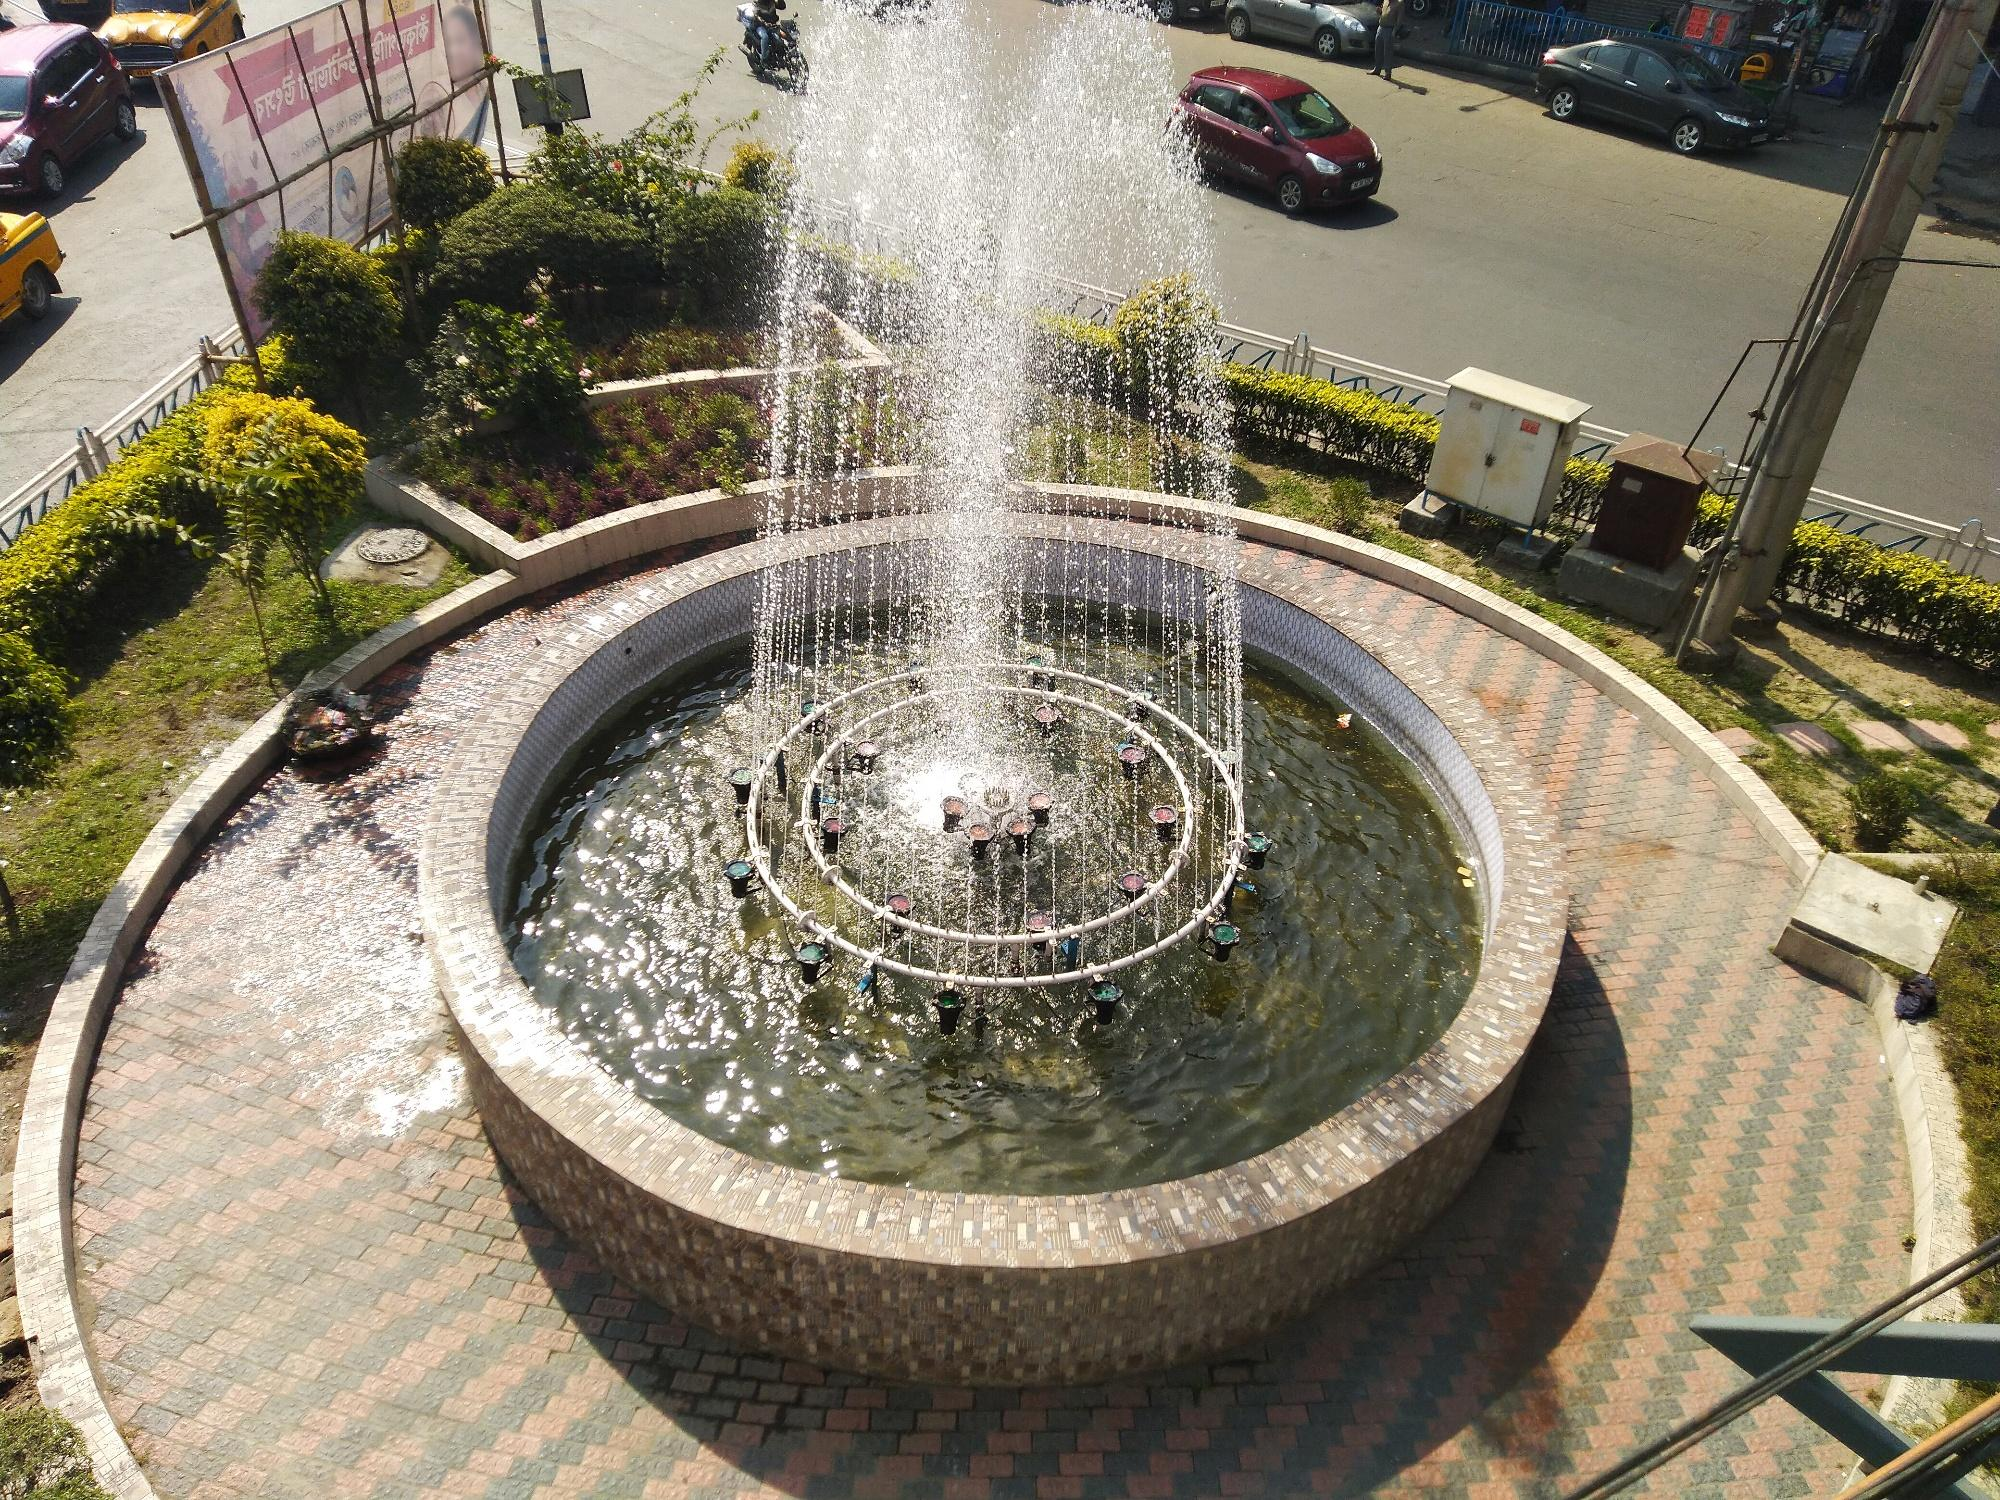How would you describe this fountain to someone who cannot see it? Imagine standing near a circular structure where water gracefully shoots upwards from the center, cascading in a soothing, rhythmic pattern. You feel the cool mist touch your face as the water arcs in elegant forms and falls into a pool. The base of the fountain is sturdy and smooth, made of arranged bricks forming a perfect round shape. You walk around it on patterned bricks, feeling the sun-warmed surface underfoot. Surrounding you are carefully trimmed bushes, their fresh scent mixing with the urban air and the sounds of city traffic in the background. 